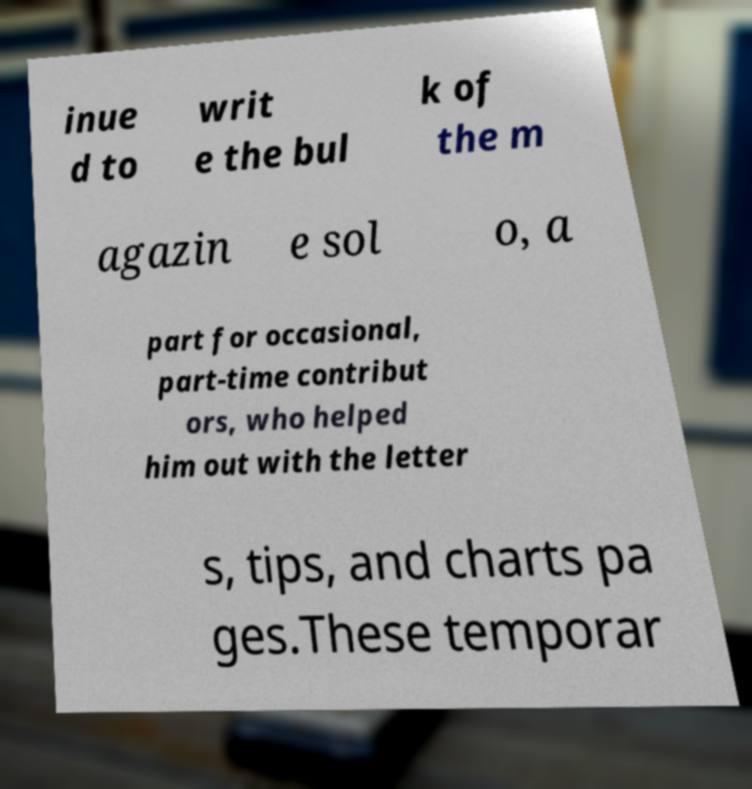What messages or text are displayed in this image? I need them in a readable, typed format. inue d to writ e the bul k of the m agazin e sol o, a part for occasional, part-time contribut ors, who helped him out with the letter s, tips, and charts pa ges.These temporar 